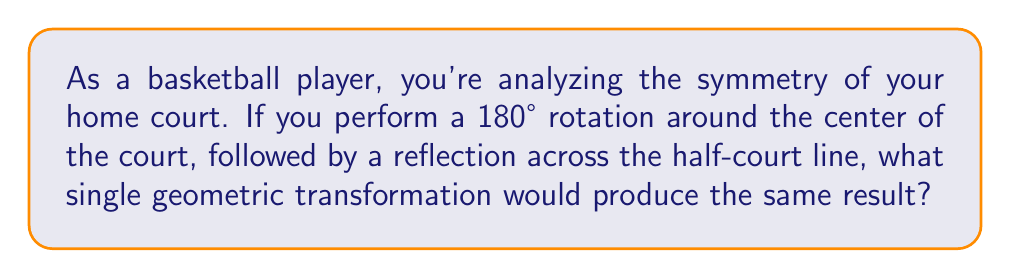Could you help me with this problem? Let's approach this step-by-step:

1) First, let's consider the effects of each transformation:
   
   a) 180° rotation around the center: This moves every point to its opposite position across the center.
   
   b) Reflection across the half-court line: This flips the court front-to-back.

2) Now, let's think about the combined effect:
   
   - The rotation moves everything to the opposite side.
   - The reflection then flips it front-to-back.

3) The net result is that every point ends up on the same side of the court as it started, but flipped left-to-right.

4) In geometric terms, a transformation that flips an object left-to-right (or right-to-left) is called a reflection across a vertical line.

5) In this case, the line of reflection would be the vertical line passing through the center of the court (perpendicular to the half-court line).

6) We can verify this:
   
   - A point on the left side near the baseline would end up on the left side near the half-court line.
   - A point on the right side near the three-point line would end up on the right side, mirrored across the center line.

7) Therefore, the single transformation that would produce the same result is a reflection across the vertical center line of the court.
Answer: Reflection across the vertical center line 